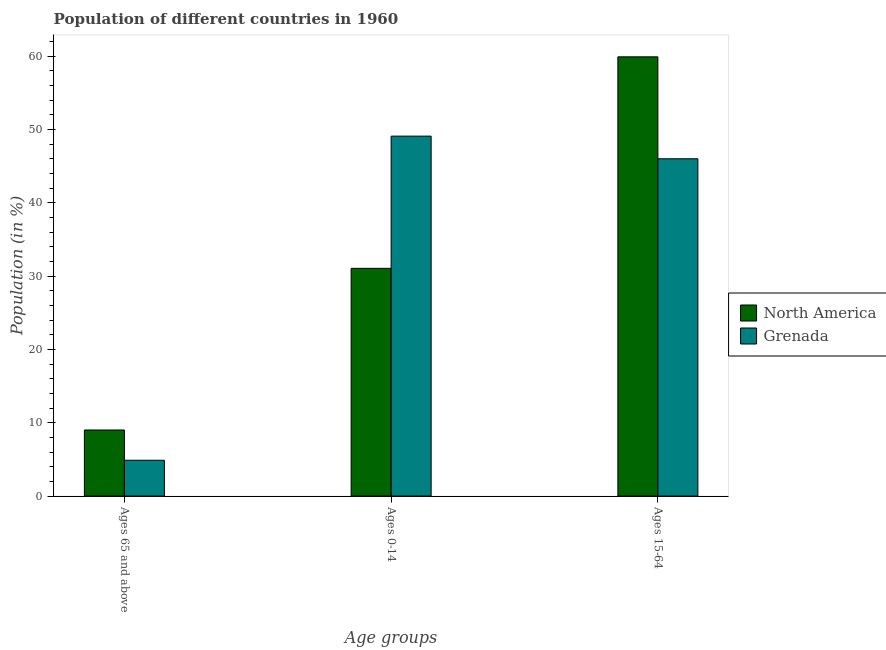How many different coloured bars are there?
Offer a very short reply. 2. How many groups of bars are there?
Keep it short and to the point. 3. Are the number of bars per tick equal to the number of legend labels?
Provide a short and direct response. Yes. Are the number of bars on each tick of the X-axis equal?
Make the answer very short. Yes. How many bars are there on the 2nd tick from the left?
Keep it short and to the point. 2. How many bars are there on the 3rd tick from the right?
Ensure brevity in your answer.  2. What is the label of the 1st group of bars from the left?
Your answer should be compact. Ages 65 and above. What is the percentage of population within the age-group 0-14 in North America?
Your answer should be very brief. 31.07. Across all countries, what is the maximum percentage of population within the age-group 15-64?
Offer a very short reply. 59.92. Across all countries, what is the minimum percentage of population within the age-group 0-14?
Make the answer very short. 31.07. In which country was the percentage of population within the age-group of 65 and above maximum?
Your answer should be compact. North America. What is the total percentage of population within the age-group 15-64 in the graph?
Keep it short and to the point. 105.93. What is the difference between the percentage of population within the age-group 15-64 in Grenada and that in North America?
Ensure brevity in your answer.  -13.91. What is the difference between the percentage of population within the age-group 0-14 in North America and the percentage of population within the age-group of 65 and above in Grenada?
Ensure brevity in your answer.  26.18. What is the average percentage of population within the age-group 15-64 per country?
Your answer should be compact. 52.97. What is the difference between the percentage of population within the age-group of 65 and above and percentage of population within the age-group 0-14 in North America?
Offer a very short reply. -22.05. What is the ratio of the percentage of population within the age-group 0-14 in Grenada to that in North America?
Provide a succinct answer. 1.58. What is the difference between the highest and the second highest percentage of population within the age-group 15-64?
Your answer should be compact. 13.91. What is the difference between the highest and the lowest percentage of population within the age-group 15-64?
Your answer should be compact. 13.91. Is the sum of the percentage of population within the age-group 15-64 in Grenada and North America greater than the maximum percentage of population within the age-group 0-14 across all countries?
Ensure brevity in your answer.  Yes. What does the 2nd bar from the left in Ages 0-14 represents?
Your response must be concise. Grenada. What does the 1st bar from the right in Ages 0-14 represents?
Your answer should be very brief. Grenada. Are all the bars in the graph horizontal?
Ensure brevity in your answer.  No. How many countries are there in the graph?
Provide a succinct answer. 2. What is the difference between two consecutive major ticks on the Y-axis?
Keep it short and to the point. 10. Does the graph contain any zero values?
Provide a short and direct response. No. Does the graph contain grids?
Make the answer very short. No. Where does the legend appear in the graph?
Offer a very short reply. Center right. What is the title of the graph?
Your answer should be compact. Population of different countries in 1960. Does "Nicaragua" appear as one of the legend labels in the graph?
Make the answer very short. No. What is the label or title of the X-axis?
Offer a very short reply. Age groups. What is the label or title of the Y-axis?
Make the answer very short. Population (in %). What is the Population (in %) in North America in Ages 65 and above?
Offer a terse response. 9.01. What is the Population (in %) in Grenada in Ages 65 and above?
Offer a very short reply. 4.88. What is the Population (in %) of North America in Ages 0-14?
Give a very brief answer. 31.07. What is the Population (in %) in Grenada in Ages 0-14?
Offer a very short reply. 49.1. What is the Population (in %) in North America in Ages 15-64?
Your response must be concise. 59.92. What is the Population (in %) of Grenada in Ages 15-64?
Provide a succinct answer. 46.01. Across all Age groups, what is the maximum Population (in %) of North America?
Offer a terse response. 59.92. Across all Age groups, what is the maximum Population (in %) of Grenada?
Your response must be concise. 49.1. Across all Age groups, what is the minimum Population (in %) in North America?
Keep it short and to the point. 9.01. Across all Age groups, what is the minimum Population (in %) in Grenada?
Make the answer very short. 4.88. What is the difference between the Population (in %) of North America in Ages 65 and above and that in Ages 0-14?
Keep it short and to the point. -22.05. What is the difference between the Population (in %) of Grenada in Ages 65 and above and that in Ages 0-14?
Provide a succinct answer. -44.22. What is the difference between the Population (in %) of North America in Ages 65 and above and that in Ages 15-64?
Give a very brief answer. -50.91. What is the difference between the Population (in %) in Grenada in Ages 65 and above and that in Ages 15-64?
Make the answer very short. -41.13. What is the difference between the Population (in %) of North America in Ages 0-14 and that in Ages 15-64?
Keep it short and to the point. -28.85. What is the difference between the Population (in %) in Grenada in Ages 0-14 and that in Ages 15-64?
Provide a short and direct response. 3.09. What is the difference between the Population (in %) of North America in Ages 65 and above and the Population (in %) of Grenada in Ages 0-14?
Your answer should be very brief. -40.09. What is the difference between the Population (in %) in North America in Ages 65 and above and the Population (in %) in Grenada in Ages 15-64?
Make the answer very short. -37. What is the difference between the Population (in %) of North America in Ages 0-14 and the Population (in %) of Grenada in Ages 15-64?
Your response must be concise. -14.95. What is the average Population (in %) of North America per Age groups?
Provide a short and direct response. 33.33. What is the average Population (in %) in Grenada per Age groups?
Your answer should be very brief. 33.33. What is the difference between the Population (in %) in North America and Population (in %) in Grenada in Ages 65 and above?
Ensure brevity in your answer.  4.13. What is the difference between the Population (in %) of North America and Population (in %) of Grenada in Ages 0-14?
Make the answer very short. -18.03. What is the difference between the Population (in %) of North America and Population (in %) of Grenada in Ages 15-64?
Offer a very short reply. 13.91. What is the ratio of the Population (in %) in North America in Ages 65 and above to that in Ages 0-14?
Your answer should be compact. 0.29. What is the ratio of the Population (in %) of Grenada in Ages 65 and above to that in Ages 0-14?
Your answer should be very brief. 0.1. What is the ratio of the Population (in %) of North America in Ages 65 and above to that in Ages 15-64?
Offer a very short reply. 0.15. What is the ratio of the Population (in %) of Grenada in Ages 65 and above to that in Ages 15-64?
Provide a succinct answer. 0.11. What is the ratio of the Population (in %) in North America in Ages 0-14 to that in Ages 15-64?
Give a very brief answer. 0.52. What is the ratio of the Population (in %) in Grenada in Ages 0-14 to that in Ages 15-64?
Make the answer very short. 1.07. What is the difference between the highest and the second highest Population (in %) of North America?
Your answer should be compact. 28.85. What is the difference between the highest and the second highest Population (in %) in Grenada?
Your answer should be compact. 3.09. What is the difference between the highest and the lowest Population (in %) in North America?
Make the answer very short. 50.91. What is the difference between the highest and the lowest Population (in %) in Grenada?
Give a very brief answer. 44.22. 